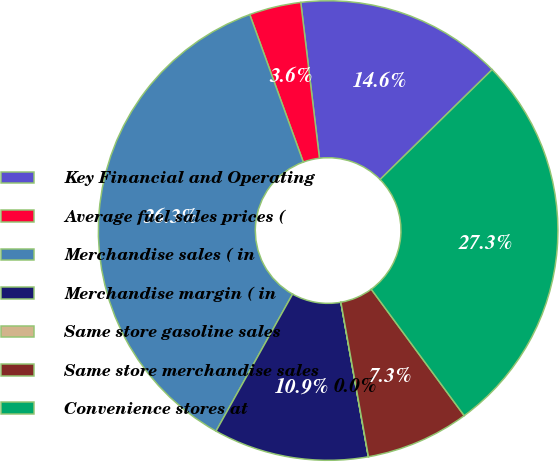<chart> <loc_0><loc_0><loc_500><loc_500><pie_chart><fcel>Key Financial and Operating<fcel>Average fuel sales prices (<fcel>Merchandise sales ( in<fcel>Merchandise margin ( in<fcel>Same store gasoline sales<fcel>Same store merchandise sales<fcel>Convenience stores at<nl><fcel>14.55%<fcel>3.64%<fcel>36.35%<fcel>10.91%<fcel>0.01%<fcel>7.28%<fcel>27.26%<nl></chart> 